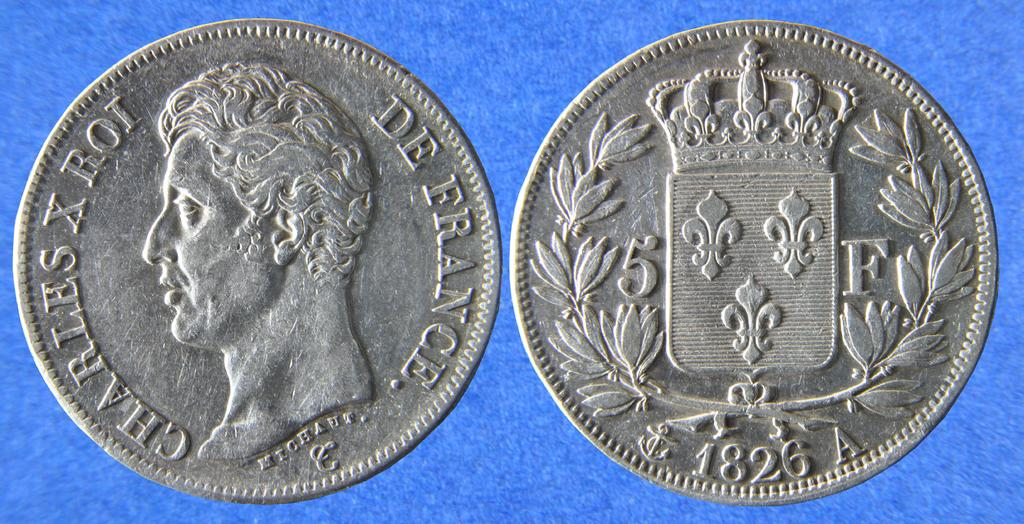<image>
Give a short and clear explanation of the subsequent image. A French coin from 1826 has a face on one site and an emblem on the back. 